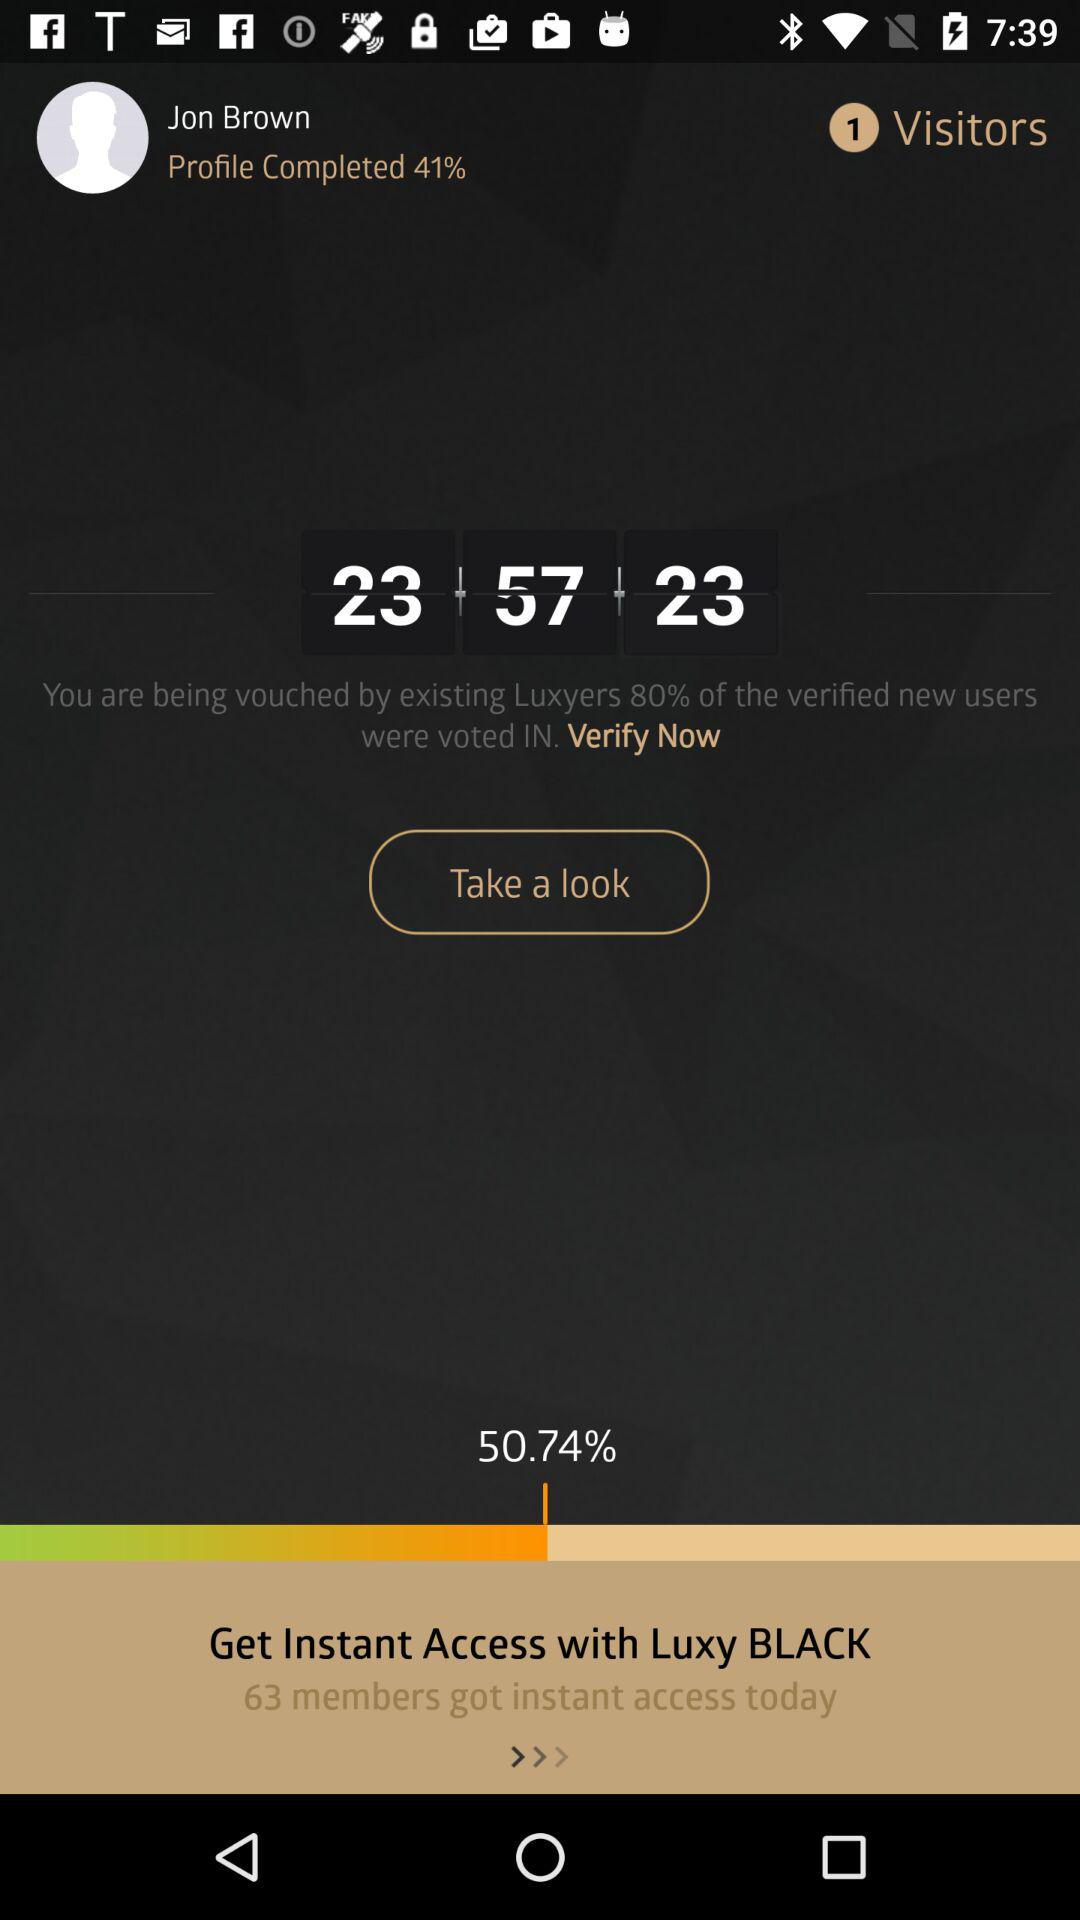How many percent of the verified new users were voted in?
Answer the question using a single word or phrase. 80% 